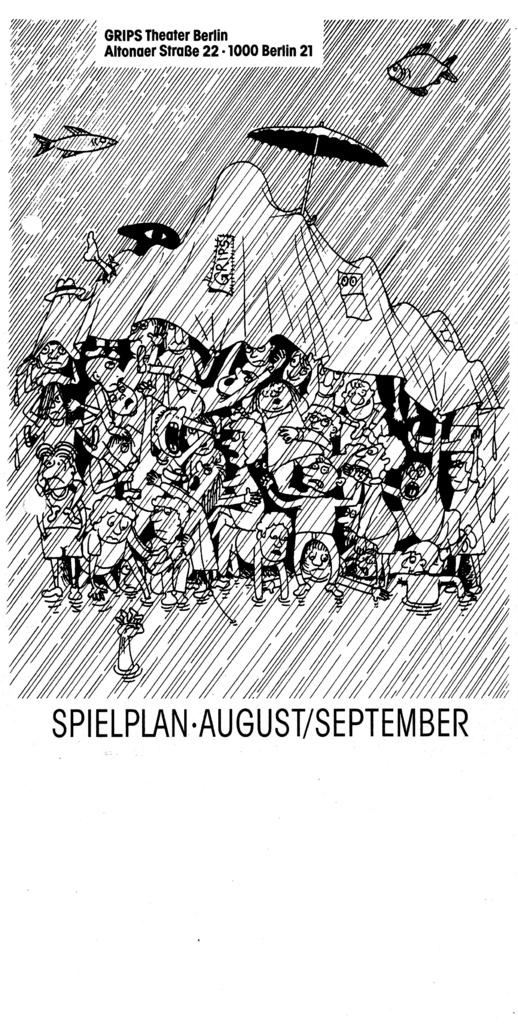What can be found in the foreground of the poster? In the foreground of the poster, there is text, a sketch of people, a sketch of a cloth, a sketch of an umbrella, a sketch of fishes, and a sketch of rain. Can you describe the sketch of people in the foreground? The sketch of people in the foreground shows people interacting with each other and the other elements in the scene. What is the subject matter of the poster? The poster appears to depict a scene involving people, a cloth, an umbrella, fishes, and rain. What type of stamp is visible on the cloth in the poster? There is no stamp visible on the cloth in the poster; it is a sketch of a cloth. Is there a band playing music in the poster? There is no mention of a band or music in the provided facts, and therefore it cannot be determined if a band is present in the poster. 